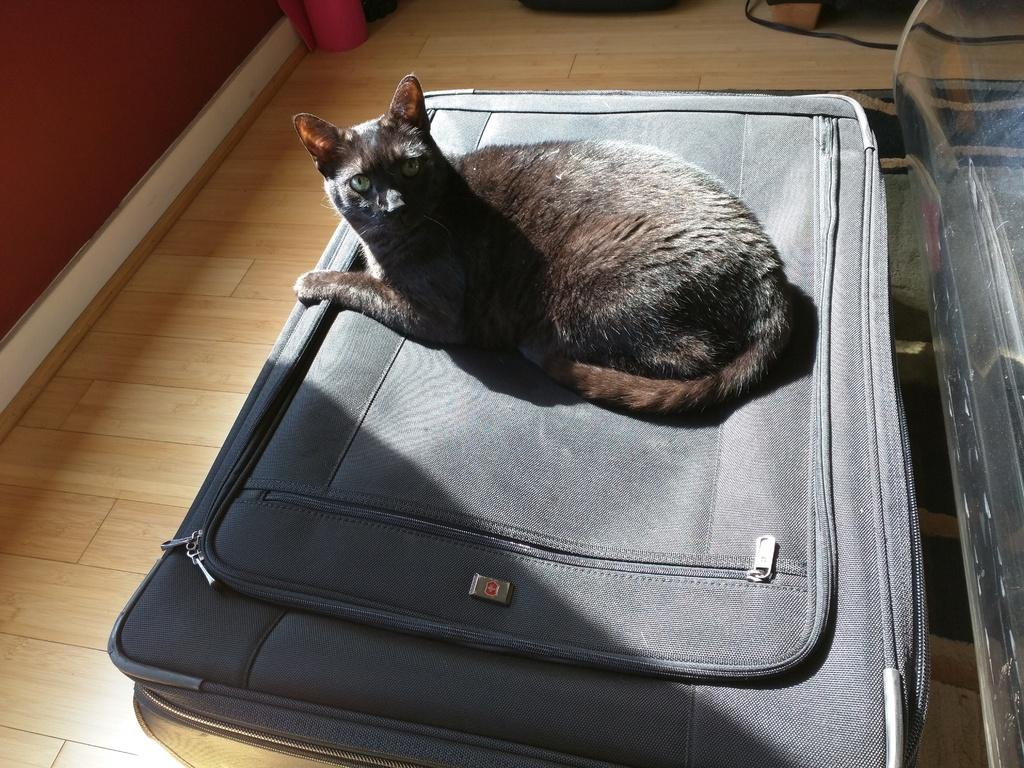What type of animal is in the image? There is a black cat in the image. What is the cat sitting on? The cat is sitting on a luggage bag. Where is the luggage bag located? The luggage bag is placed on the floor. Can you hear the sound of bells coming from the cat in the image? There is no mention of bells or any sound in the image, so it cannot be determined if the cat is making any noise. 